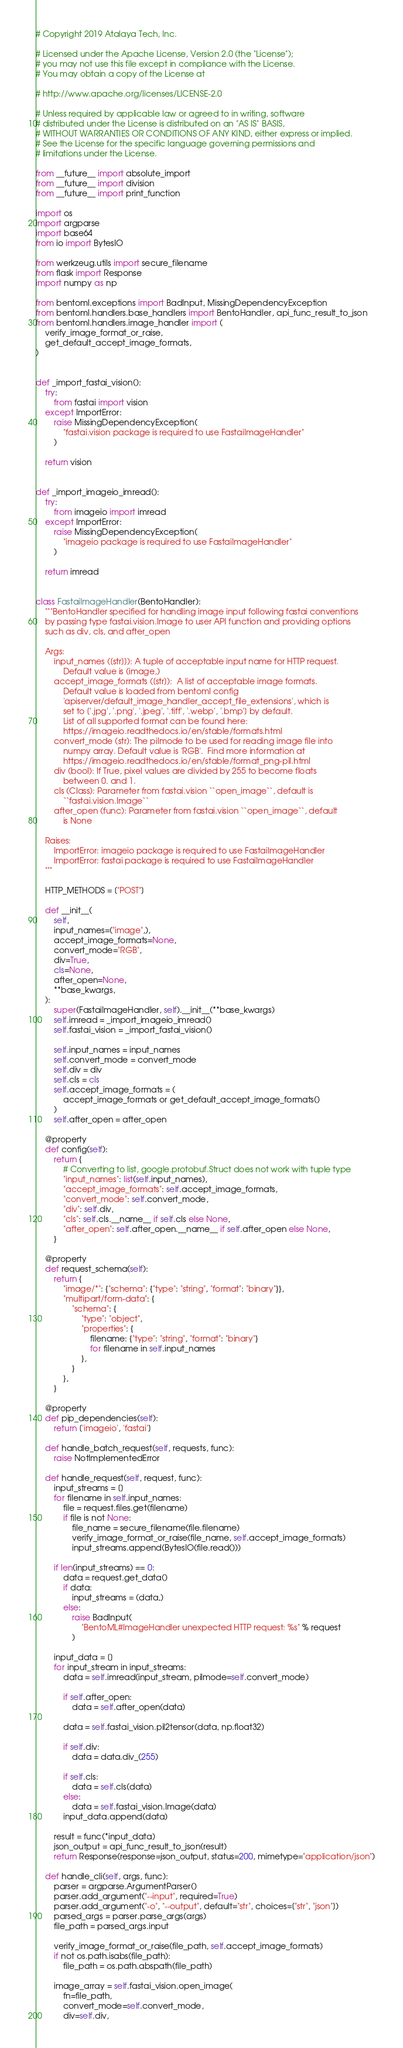Convert code to text. <code><loc_0><loc_0><loc_500><loc_500><_Python_># Copyright 2019 Atalaya Tech, Inc.

# Licensed under the Apache License, Version 2.0 (the "License");
# you may not use this file except in compliance with the License.
# You may obtain a copy of the License at

# http://www.apache.org/licenses/LICENSE-2.0

# Unless required by applicable law or agreed to in writing, software
# distributed under the License is distributed on an "AS IS" BASIS,
# WITHOUT WARRANTIES OR CONDITIONS OF ANY KIND, either express or implied.
# See the License for the specific language governing permissions and
# limitations under the License.

from __future__ import absolute_import
from __future__ import division
from __future__ import print_function

import os
import argparse
import base64
from io import BytesIO

from werkzeug.utils import secure_filename
from flask import Response
import numpy as np

from bentoml.exceptions import BadInput, MissingDependencyException
from bentoml.handlers.base_handlers import BentoHandler, api_func_result_to_json
from bentoml.handlers.image_handler import (
    verify_image_format_or_raise,
    get_default_accept_image_formats,
)


def _import_fastai_vision():
    try:
        from fastai import vision
    except ImportError:
        raise MissingDependencyException(
            "fastai.vision package is required to use FastaiImageHandler"
        )

    return vision


def _import_imageio_imread():
    try:
        from imageio import imread
    except ImportError:
        raise MissingDependencyException(
            "imageio package is required to use FastaiImageHandler"
        )

    return imread


class FastaiImageHandler(BentoHandler):
    """BentoHandler specified for handling image input following fastai conventions
    by passing type fastai.vision.Image to user API function and providing options
    such as div, cls, and after_open

    Args:
        input_names ([str]]): A tuple of acceptable input name for HTTP request.
            Default value is (image,)
        accept_image_formats ([str]):  A list of acceptable image formats.
            Default value is loaded from bentoml config
            'apiserver/default_image_handler_accept_file_extensions', which is
            set to ['.jpg', '.png', '.jpeg', '.tiff', '.webp', '.bmp'] by default.
            List of all supported format can be found here:
            https://imageio.readthedocs.io/en/stable/formats.html
        convert_mode (str): The pilmode to be used for reading image file into
            numpy array. Default value is 'RGB'.  Find more information at
            https://imageio.readthedocs.io/en/stable/format_png-pil.html
        div (bool): If True, pixel values are divided by 255 to become floats
            between 0. and 1.
        cls (Class): Parameter from fastai.vision ``open_image``, default is
            ``fastai.vision.Image``
        after_open (func): Parameter from fastai.vision ``open_image``, default
            is None

    Raises:
        ImportError: imageio package is required to use FastaiImageHandler
        ImportError: fastai package is required to use FastaiImageHandler
    """

    HTTP_METHODS = ["POST"]

    def __init__(
        self,
        input_names=("image",),
        accept_image_formats=None,
        convert_mode="RGB",
        div=True,
        cls=None,
        after_open=None,
        **base_kwargs,
    ):
        super(FastaiImageHandler, self).__init__(**base_kwargs)
        self.imread = _import_imageio_imread()
        self.fastai_vision = _import_fastai_vision()

        self.input_names = input_names
        self.convert_mode = convert_mode
        self.div = div
        self.cls = cls
        self.accept_image_formats = (
            accept_image_formats or get_default_accept_image_formats()
        )
        self.after_open = after_open

    @property
    def config(self):
        return {
            # Converting to list, google.protobuf.Struct does not work with tuple type
            "input_names": list(self.input_names),
            "accept_image_formats": self.accept_image_formats,
            "convert_mode": self.convert_mode,
            "div": self.div,
            "cls": self.cls.__name__ if self.cls else None,
            "after_open": self.after_open.__name__ if self.after_open else None,
        }

    @property
    def request_schema(self):
        return {
            "image/*": {"schema": {"type": "string", "format": "binary"}},
            "multipart/form-data": {
                "schema": {
                    "type": "object",
                    "properties": {
                        filename: {"type": "string", "format": "binary"}
                        for filename in self.input_names
                    },
                }
            },
        }

    @property
    def pip_dependencies(self):
        return ['imageio', 'fastai']

    def handle_batch_request(self, requests, func):
        raise NotImplementedError

    def handle_request(self, request, func):
        input_streams = []
        for filename in self.input_names:
            file = request.files.get(filename)
            if file is not None:
                file_name = secure_filename(file.filename)
                verify_image_format_or_raise(file_name, self.accept_image_formats)
                input_streams.append(BytesIO(file.read()))

        if len(input_streams) == 0:
            data = request.get_data()
            if data:
                input_streams = (data,)
            else:
                raise BadInput(
                    "BentoML#ImageHandler unexpected HTTP request: %s" % request
                )

        input_data = []
        for input_stream in input_streams:
            data = self.imread(input_stream, pilmode=self.convert_mode)

            if self.after_open:
                data = self.after_open(data)

            data = self.fastai_vision.pil2tensor(data, np.float32)

            if self.div:
                data = data.div_(255)

            if self.cls:
                data = self.cls(data)
            else:
                data = self.fastai_vision.Image(data)
            input_data.append(data)

        result = func(*input_data)
        json_output = api_func_result_to_json(result)
        return Response(response=json_output, status=200, mimetype="application/json")

    def handle_cli(self, args, func):
        parser = argparse.ArgumentParser()
        parser.add_argument("--input", required=True)
        parser.add_argument("-o", "--output", default="str", choices=["str", "json"])
        parsed_args = parser.parse_args(args)
        file_path = parsed_args.input

        verify_image_format_or_raise(file_path, self.accept_image_formats)
        if not os.path.isabs(file_path):
            file_path = os.path.abspath(file_path)

        image_array = self.fastai_vision.open_image(
            fn=file_path,
            convert_mode=self.convert_mode,
            div=self.div,</code> 